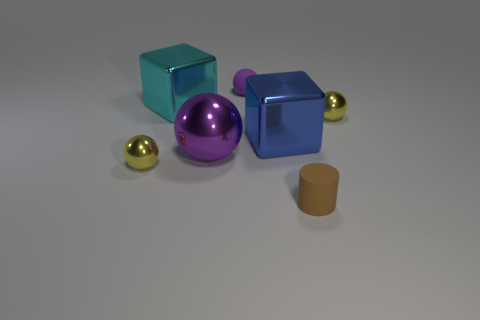There is a tiny yellow ball that is left of the metal cube to the left of the big block to the right of the small rubber ball; what is it made of?
Offer a terse response. Metal. The purple thing that is the same size as the blue shiny cube is what shape?
Your response must be concise. Sphere. How many objects are either yellow metal spheres or small things that are left of the cyan block?
Provide a short and direct response. 2. Is the material of the yellow ball on the right side of the tiny brown cylinder the same as the big cube behind the blue metal object?
Offer a terse response. Yes. What is the shape of the large metal thing that is the same color as the small matte sphere?
Keep it short and to the point. Sphere. What number of blue things are big metal things or metallic blocks?
Your response must be concise. 1. What size is the purple metal sphere?
Your answer should be compact. Large. Is the number of large purple objects that are in front of the big ball greater than the number of small brown rubber things?
Offer a terse response. No. How many large blue shiny objects are on the left side of the blue shiny object?
Your answer should be very brief. 0. Are there any purple spheres that have the same size as the purple matte thing?
Provide a short and direct response. No. 